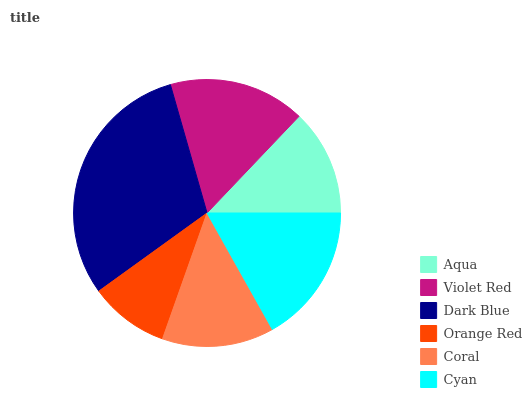Is Orange Red the minimum?
Answer yes or no. Yes. Is Dark Blue the maximum?
Answer yes or no. Yes. Is Violet Red the minimum?
Answer yes or no. No. Is Violet Red the maximum?
Answer yes or no. No. Is Violet Red greater than Aqua?
Answer yes or no. Yes. Is Aqua less than Violet Red?
Answer yes or no. Yes. Is Aqua greater than Violet Red?
Answer yes or no. No. Is Violet Red less than Aqua?
Answer yes or no. No. Is Violet Red the high median?
Answer yes or no. Yes. Is Coral the low median?
Answer yes or no. Yes. Is Dark Blue the high median?
Answer yes or no. No. Is Dark Blue the low median?
Answer yes or no. No. 